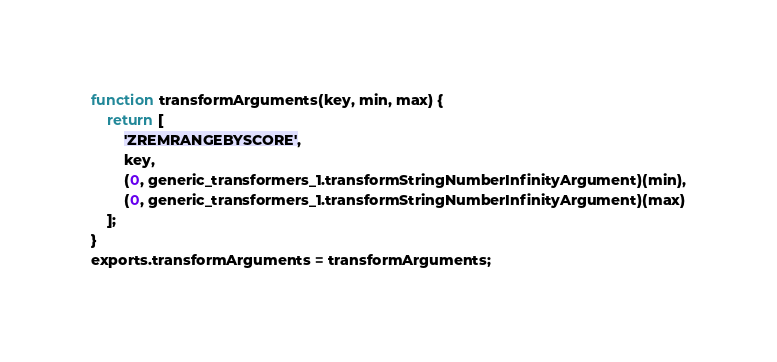Convert code to text. <code><loc_0><loc_0><loc_500><loc_500><_JavaScript_>function transformArguments(key, min, max) {
    return [
        'ZREMRANGEBYSCORE',
        key,
        (0, generic_transformers_1.transformStringNumberInfinityArgument)(min),
        (0, generic_transformers_1.transformStringNumberInfinityArgument)(max)
    ];
}
exports.transformArguments = transformArguments;
</code> 